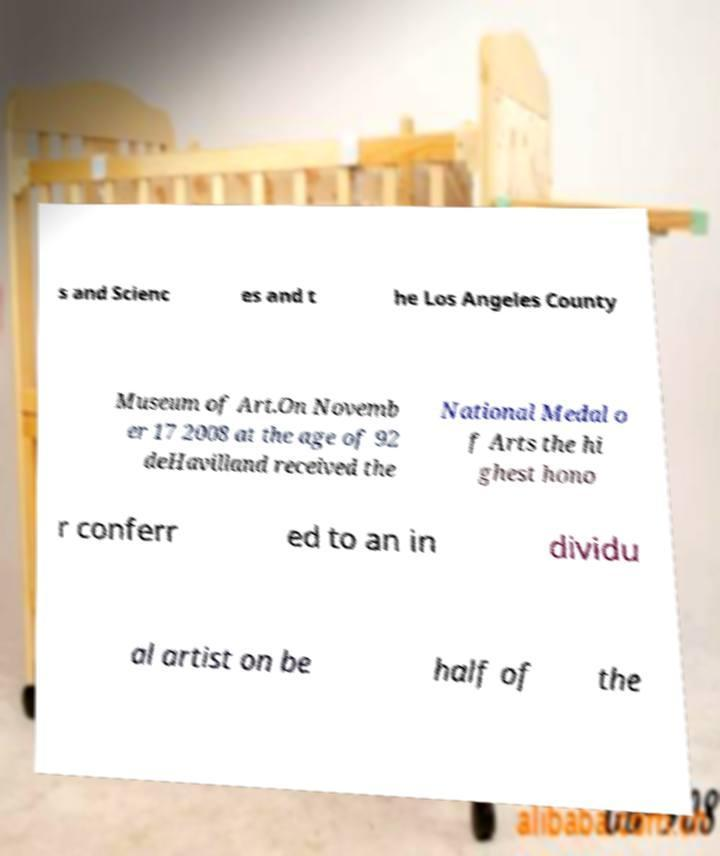Please read and relay the text visible in this image. What does it say? s and Scienc es and t he Los Angeles County Museum of Art.On Novemb er 17 2008 at the age of 92 deHavilland received the National Medal o f Arts the hi ghest hono r conferr ed to an in dividu al artist on be half of the 